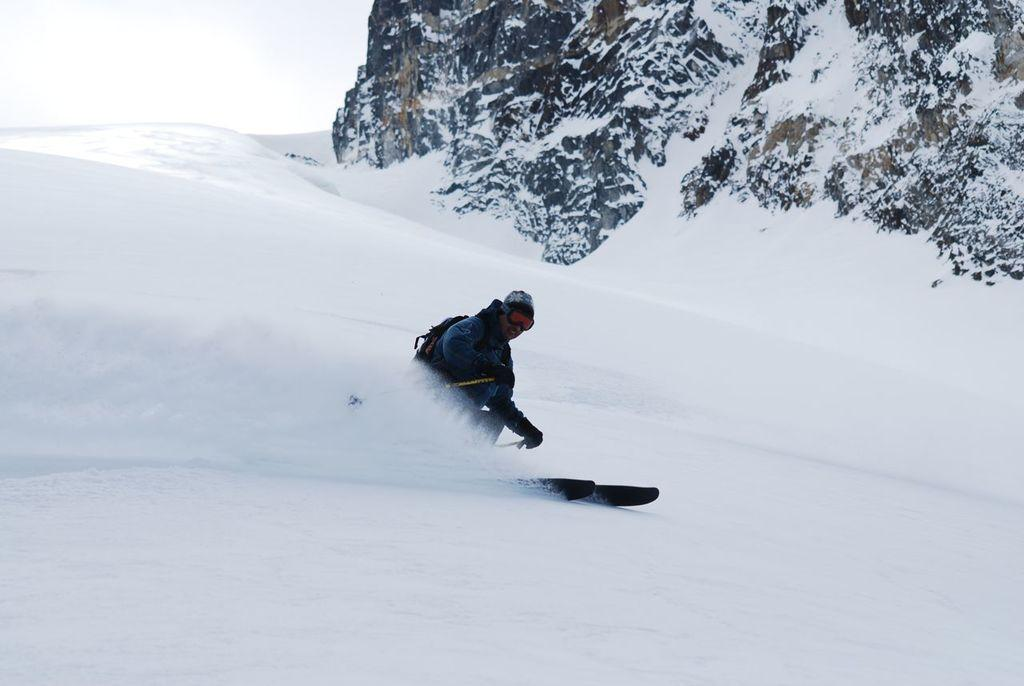What type of surface is shown in the image? The image shows a snow surface. What activity is the person in the image engaged in? The person is skating on a snowboard in the image. What other objects can be seen in the image besides the person and the snow surface? Rocks are visible in the image. How are the rocks affected by the snow in the image? The rocks have snow on them. What type of plantation can be seen in the background of the image? There is no plantation present in the image; it shows a snow surface with a person skating on a snowboard and rocks with snow on them. 